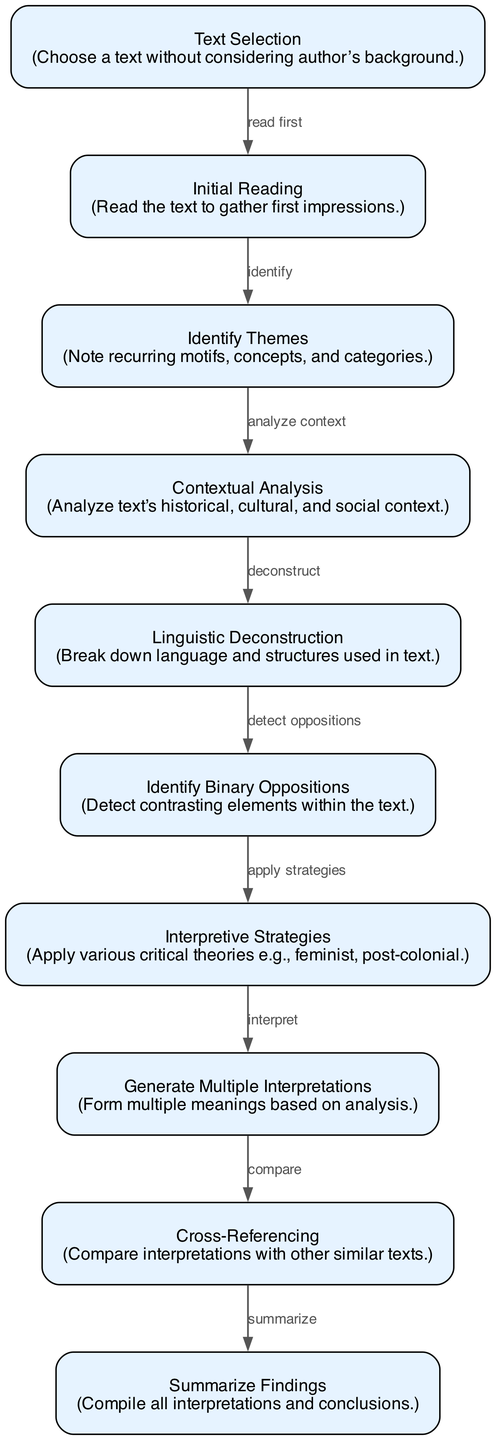What is the first step in the decoding process? The first step in the flowchart is "Text Selection." It indicates that one must choose a text without considering the author's background.
Answer: Text Selection How many nodes are present in the diagram? To find the number of nodes, simply count the entries listed under "nodes" in the data. There are ten distinct nodes in the flowchart.
Answer: 10 What step follows "Identify Binary Oppositions"? Following the "Identify Binary Oppositions" step, the next step in the flowchart is "Interpretive Strategies." This connection is shown by the labeled edge between these two nodes.
Answer: Interpretive Strategies What is the main purpose of "Generate Multiple Interpretations"? The main purpose of the "Generate Multiple Interpretations" node is to form multiple meanings based on previous analysis steps. This indicates a culmination of the prior processes into various interpretations.
Answer: Form multiple meanings How do you move from "Contextual Analysis" to "Linguistic Deconstruction"? The diagram shows a directed connection from "Contextual Analysis" to "Linguistic Deconstruction" indicating that once context has been analyzed, it leads directly into breaking down the language and structures used in the text, showcasing a logical flow in analysis.
Answer: Deconstruct What critical theories can be applied during "Interpretive Strategies"? The node "Interpretive Strategies" suggests applying various critical theories such as feminist and post-colonial theories. This emphasizes a multi-perspective approach in literary analysis.
Answer: Various critical theories How do "Generate Multiple Interpretations" and "Cross-Referencing" relate? "Generate Multiple Interpretations" leads directly to "Cross-Referencing," suggesting that once multiple meanings are established, they are compared with other similar texts as part of the analytical process.
Answer: Compare interpretations What is the final outcome of the decoding process? The final outcome of the decoding process in the flowchart is "Summarize Findings," where all interpretations and conclusions are compiled after all previous steps have been completed.
Answer: Summarize Findings 